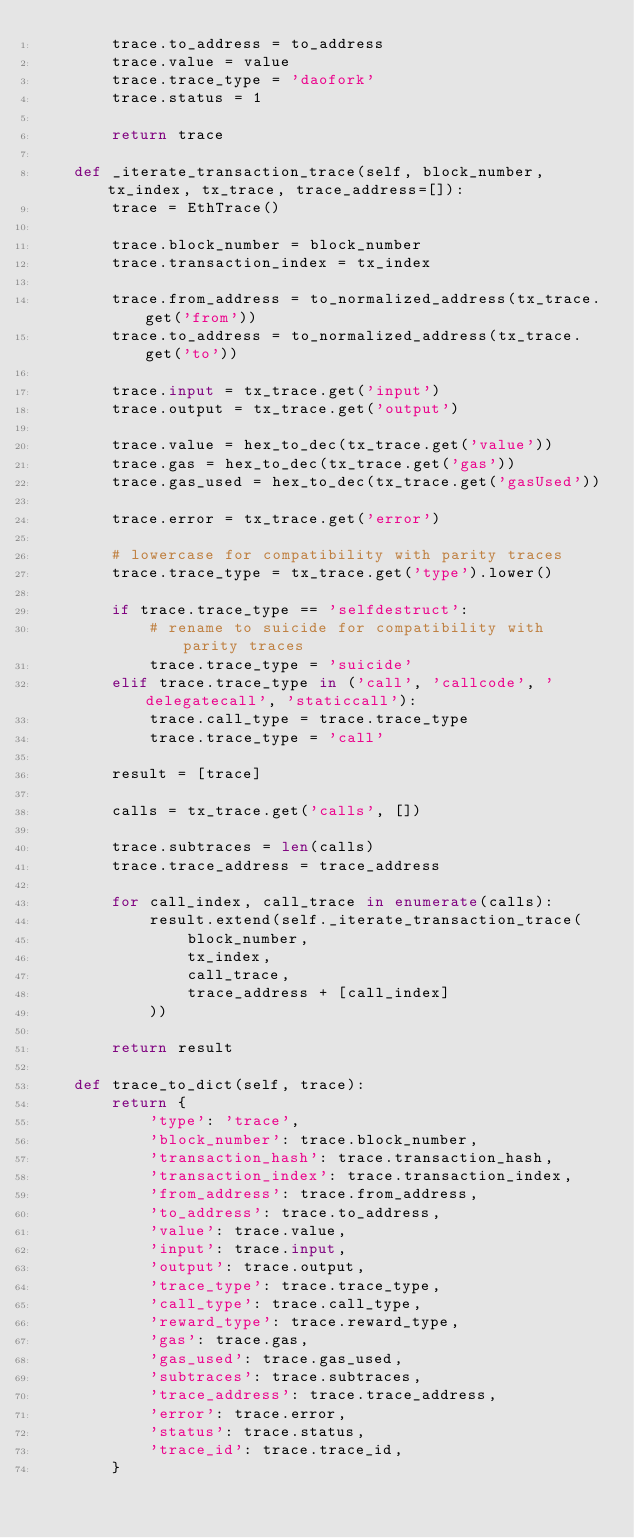<code> <loc_0><loc_0><loc_500><loc_500><_Python_>        trace.to_address = to_address
        trace.value = value
        trace.trace_type = 'daofork'
        trace.status = 1

        return trace

    def _iterate_transaction_trace(self, block_number, tx_index, tx_trace, trace_address=[]):
        trace = EthTrace()

        trace.block_number = block_number
        trace.transaction_index = tx_index

        trace.from_address = to_normalized_address(tx_trace.get('from'))
        trace.to_address = to_normalized_address(tx_trace.get('to'))

        trace.input = tx_trace.get('input')
        trace.output = tx_trace.get('output')

        trace.value = hex_to_dec(tx_trace.get('value'))
        trace.gas = hex_to_dec(tx_trace.get('gas'))
        trace.gas_used = hex_to_dec(tx_trace.get('gasUsed'))

        trace.error = tx_trace.get('error')

        # lowercase for compatibility with parity traces
        trace.trace_type = tx_trace.get('type').lower()

        if trace.trace_type == 'selfdestruct':
            # rename to suicide for compatibility with parity traces
            trace.trace_type = 'suicide'
        elif trace.trace_type in ('call', 'callcode', 'delegatecall', 'staticcall'):
            trace.call_type = trace.trace_type
            trace.trace_type = 'call'

        result = [trace]

        calls = tx_trace.get('calls', [])

        trace.subtraces = len(calls)
        trace.trace_address = trace_address

        for call_index, call_trace in enumerate(calls):
            result.extend(self._iterate_transaction_trace(
                block_number,
                tx_index,
                call_trace,
                trace_address + [call_index]
            ))

        return result

    def trace_to_dict(self, trace):
        return {
            'type': 'trace',
            'block_number': trace.block_number,
            'transaction_hash': trace.transaction_hash,
            'transaction_index': trace.transaction_index,
            'from_address': trace.from_address,
            'to_address': trace.to_address,
            'value': trace.value,
            'input': trace.input,
            'output': trace.output,
            'trace_type': trace.trace_type,
            'call_type': trace.call_type,
            'reward_type': trace.reward_type,
            'gas': trace.gas,
            'gas_used': trace.gas_used,
            'subtraces': trace.subtraces,
            'trace_address': trace.trace_address,
            'error': trace.error,
            'status': trace.status,
            'trace_id': trace.trace_id,
        }
</code> 